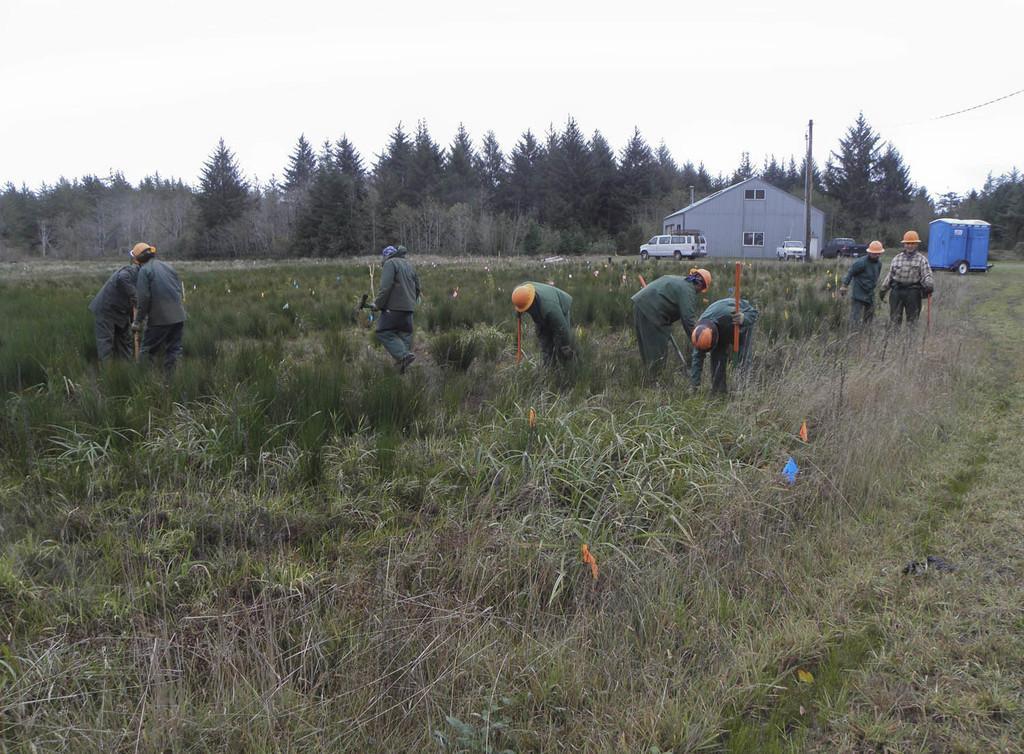Please provide a concise description of this image. In the image on the ground there is grass. There are few people standing in the middle of the grass and there are helmets on their heads. And also there are few flags. In the background there are few vehicles and a pole and a house with roofs, walls and windows. There are trees in the background. At the top of the image there is a sky with clouds. 